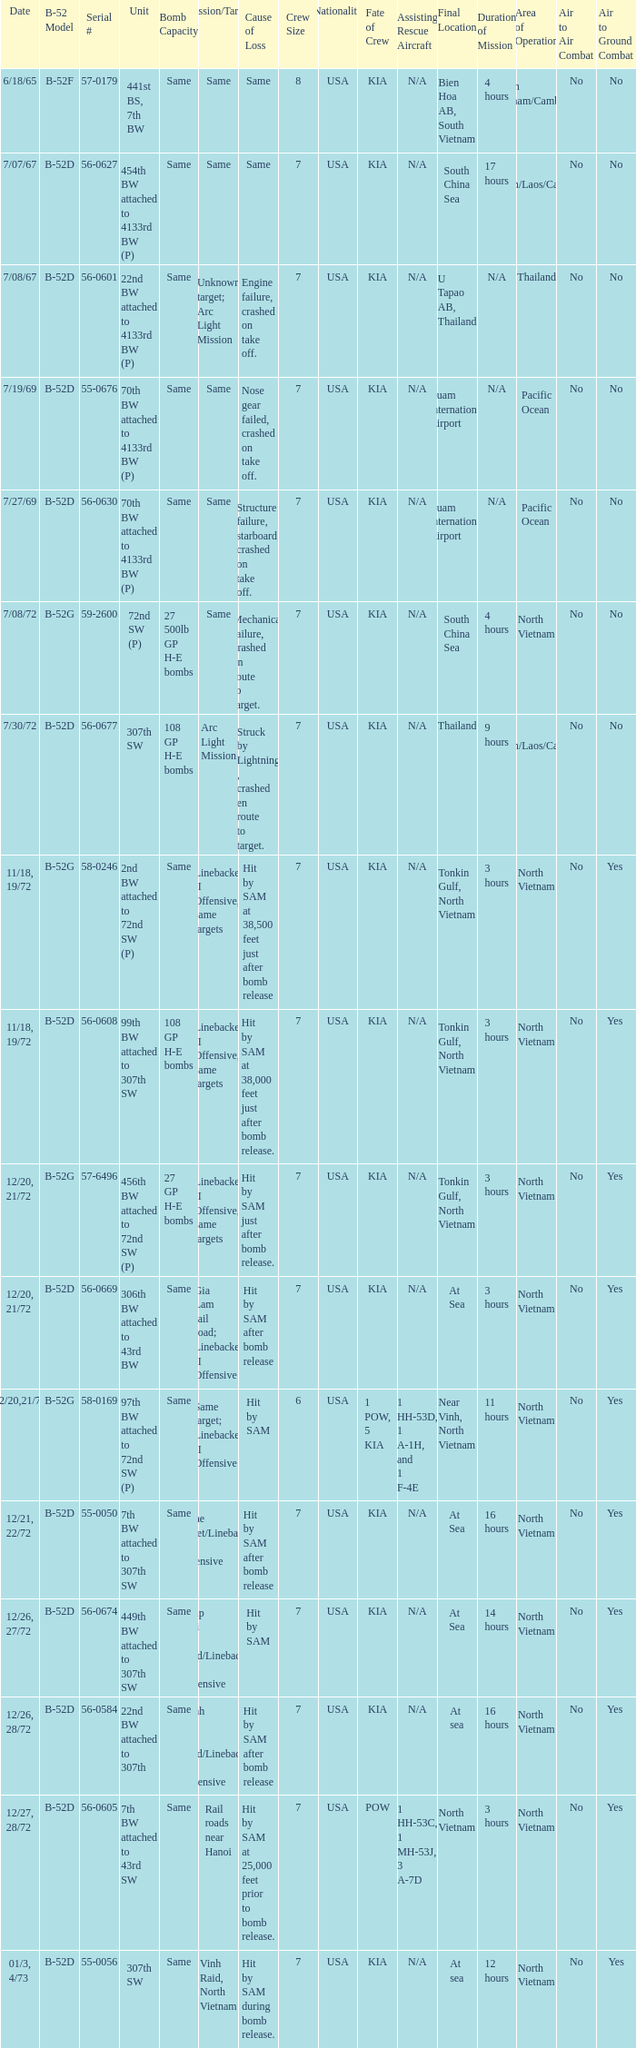When  27 gp h-e bombs the capacity of the bomb what is the cause of loss? Hit by SAM just after bomb release. 